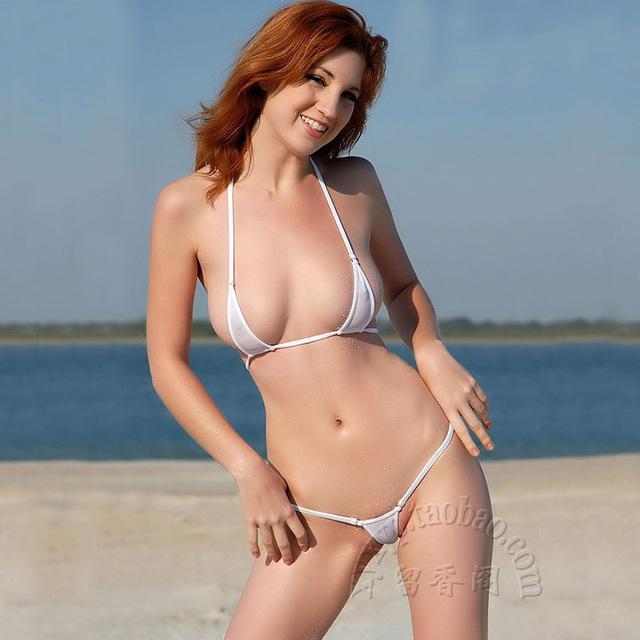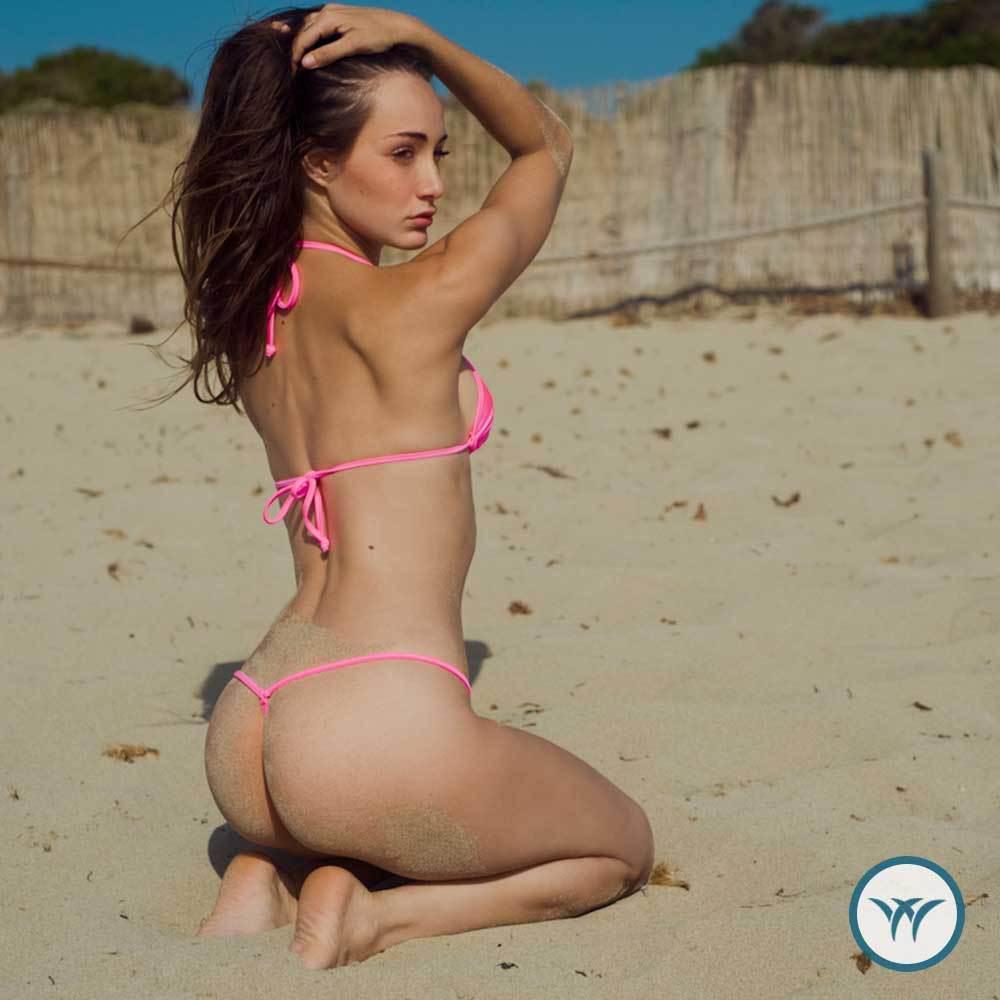The first image is the image on the left, the second image is the image on the right. Assess this claim about the two images: "The bikini belonging to the woman on the left is only one color: white.". Correct or not? Answer yes or no. Yes. The first image is the image on the left, the second image is the image on the right. Considering the images on both sides, is "Each image shows a bikini model standing with the hand on the right lifted to her hair, but only one of the models has her other arm bent at the elbow with a hand above her hip." valid? Answer yes or no. No. 